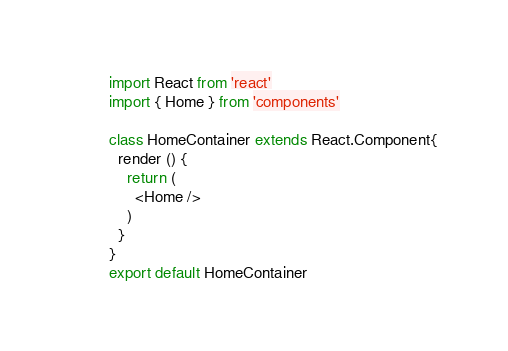Convert code to text. <code><loc_0><loc_0><loc_500><loc_500><_JavaScript_>import React from 'react'
import { Home } from 'components'

class HomeContainer extends React.Component{
  render () {
    return (
      <Home />
    )
  }
}
export default HomeContainer</code> 